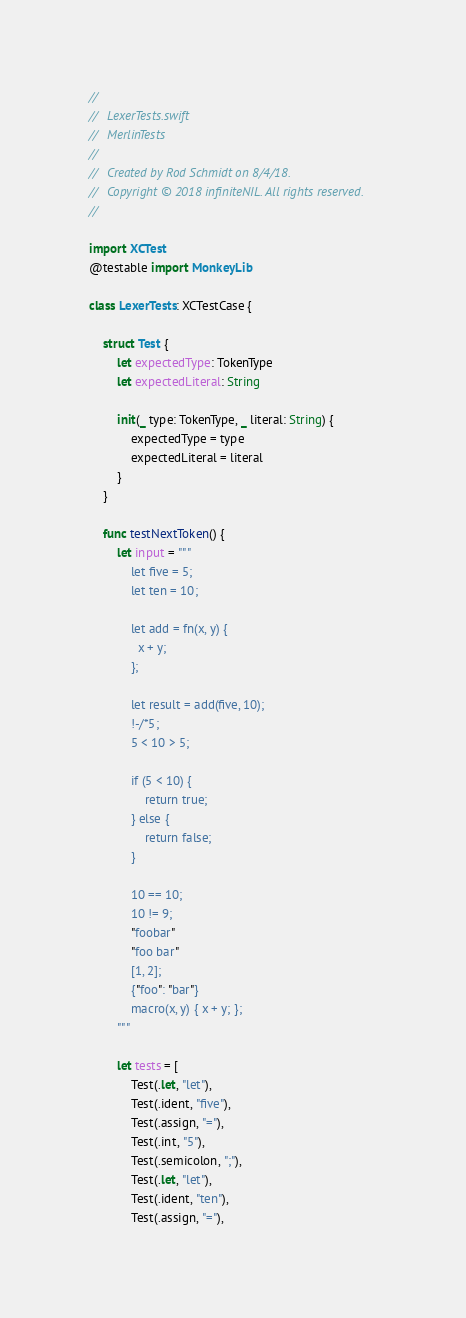Convert code to text. <code><loc_0><loc_0><loc_500><loc_500><_Swift_>//
//  LexerTests.swift
//  MerlinTests
//
//  Created by Rod Schmidt on 8/4/18.
//  Copyright © 2018 infiniteNIL. All rights reserved.
//

import XCTest
@testable import MonkeyLib

class LexerTests: XCTestCase {

    struct Test {
        let expectedType: TokenType
        let expectedLiteral: String

        init(_ type: TokenType, _ literal: String) {
            expectedType = type
            expectedLiteral = literal
        }
    }

    func testNextToken() {
        let input = """
            let five = 5;
            let ten = 10;

            let add = fn(x, y) {
              x + y;
            };

            let result = add(five, 10);
            !-/*5;
            5 < 10 > 5;

            if (5 < 10) {
                return true;
            } else {
                return false;
            }

            10 == 10;
            10 != 9;
            "foobar"
            "foo bar"
            [1, 2];
            {"foo": "bar"}
            macro(x, y) { x + y; };
        """

        let tests = [
            Test(.let, "let"),
            Test(.ident, "five"),
            Test(.assign, "="),
            Test(.int, "5"),
            Test(.semicolon, ";"),
            Test(.let, "let"),
            Test(.ident, "ten"),
            Test(.assign, "="),</code> 